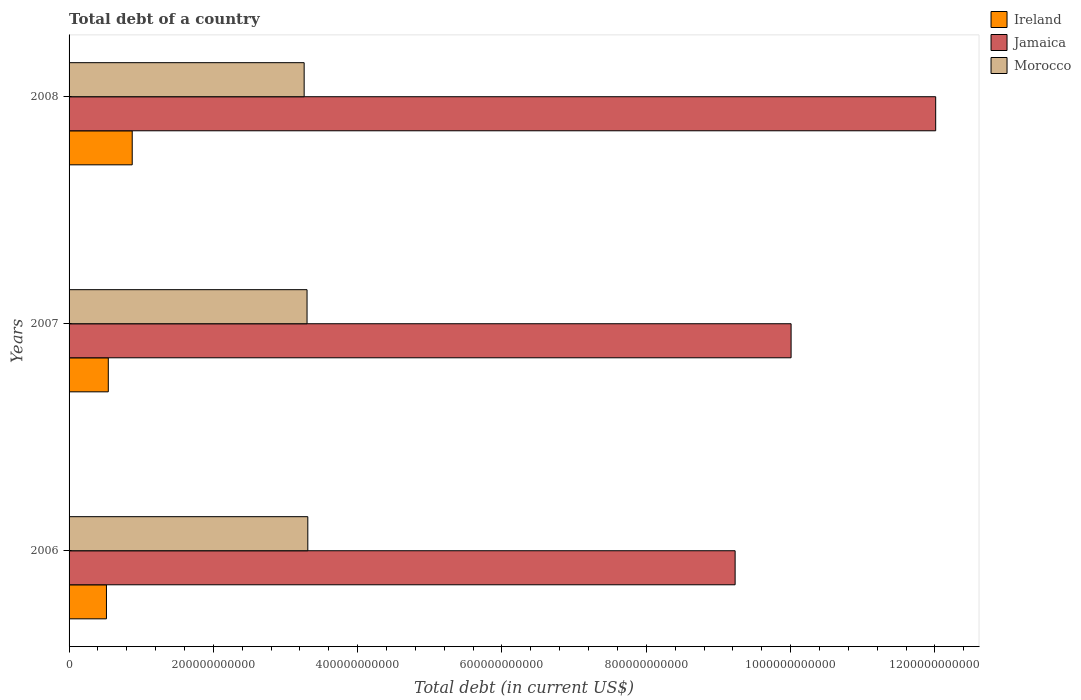Are the number of bars per tick equal to the number of legend labels?
Offer a very short reply. Yes. Are the number of bars on each tick of the Y-axis equal?
Your response must be concise. Yes. How many bars are there on the 3rd tick from the top?
Keep it short and to the point. 3. In how many cases, is the number of bars for a given year not equal to the number of legend labels?
Your answer should be very brief. 0. What is the debt in Ireland in 2008?
Make the answer very short. 8.75e+1. Across all years, what is the maximum debt in Morocco?
Offer a terse response. 3.31e+11. Across all years, what is the minimum debt in Jamaica?
Provide a succinct answer. 9.23e+11. What is the total debt in Morocco in the graph?
Your response must be concise. 9.87e+11. What is the difference between the debt in Jamaica in 2006 and that in 2007?
Make the answer very short. -7.76e+1. What is the difference between the debt in Ireland in 2006 and the debt in Jamaica in 2008?
Provide a succinct answer. -1.15e+12. What is the average debt in Ireland per year?
Your answer should be very brief. 6.46e+1. In the year 2008, what is the difference between the debt in Jamaica and debt in Ireland?
Ensure brevity in your answer.  1.11e+12. In how many years, is the debt in Ireland greater than 680000000000 US$?
Keep it short and to the point. 0. What is the ratio of the debt in Ireland in 2006 to that in 2007?
Provide a succinct answer. 0.95. What is the difference between the highest and the second highest debt in Ireland?
Ensure brevity in your answer.  3.32e+1. What is the difference between the highest and the lowest debt in Jamaica?
Keep it short and to the point. 2.78e+11. What does the 1st bar from the top in 2008 represents?
Offer a terse response. Morocco. What does the 2nd bar from the bottom in 2008 represents?
Your answer should be compact. Jamaica. Is it the case that in every year, the sum of the debt in Ireland and debt in Jamaica is greater than the debt in Morocco?
Your answer should be compact. Yes. How many bars are there?
Offer a very short reply. 9. Are all the bars in the graph horizontal?
Offer a terse response. Yes. How many years are there in the graph?
Your answer should be very brief. 3. What is the difference between two consecutive major ticks on the X-axis?
Your response must be concise. 2.00e+11. Are the values on the major ticks of X-axis written in scientific E-notation?
Offer a terse response. No. Does the graph contain any zero values?
Give a very brief answer. No. Where does the legend appear in the graph?
Make the answer very short. Top right. How are the legend labels stacked?
Your answer should be compact. Vertical. What is the title of the graph?
Your answer should be compact. Total debt of a country. What is the label or title of the X-axis?
Ensure brevity in your answer.  Total debt (in current US$). What is the Total debt (in current US$) in Ireland in 2006?
Offer a very short reply. 5.18e+1. What is the Total debt (in current US$) of Jamaica in 2006?
Your response must be concise. 9.23e+11. What is the Total debt (in current US$) in Morocco in 2006?
Make the answer very short. 3.31e+11. What is the Total debt (in current US$) in Ireland in 2007?
Keep it short and to the point. 5.44e+1. What is the Total debt (in current US$) in Jamaica in 2007?
Your answer should be compact. 1.00e+12. What is the Total debt (in current US$) in Morocco in 2007?
Your answer should be compact. 3.30e+11. What is the Total debt (in current US$) of Ireland in 2008?
Provide a short and direct response. 8.75e+1. What is the Total debt (in current US$) of Jamaica in 2008?
Offer a very short reply. 1.20e+12. What is the Total debt (in current US$) in Morocco in 2008?
Offer a very short reply. 3.26e+11. Across all years, what is the maximum Total debt (in current US$) of Ireland?
Give a very brief answer. 8.75e+1. Across all years, what is the maximum Total debt (in current US$) in Jamaica?
Your answer should be compact. 1.20e+12. Across all years, what is the maximum Total debt (in current US$) in Morocco?
Your answer should be very brief. 3.31e+11. Across all years, what is the minimum Total debt (in current US$) of Ireland?
Your answer should be very brief. 5.18e+1. Across all years, what is the minimum Total debt (in current US$) in Jamaica?
Make the answer very short. 9.23e+11. Across all years, what is the minimum Total debt (in current US$) of Morocco?
Give a very brief answer. 3.26e+11. What is the total Total debt (in current US$) in Ireland in the graph?
Your response must be concise. 1.94e+11. What is the total Total debt (in current US$) of Jamaica in the graph?
Give a very brief answer. 3.12e+12. What is the total Total debt (in current US$) in Morocco in the graph?
Give a very brief answer. 9.87e+11. What is the difference between the Total debt (in current US$) of Ireland in 2006 and that in 2007?
Provide a succinct answer. -2.56e+09. What is the difference between the Total debt (in current US$) of Jamaica in 2006 and that in 2007?
Give a very brief answer. -7.76e+1. What is the difference between the Total debt (in current US$) of Morocco in 2006 and that in 2007?
Offer a terse response. 1.06e+09. What is the difference between the Total debt (in current US$) in Ireland in 2006 and that in 2008?
Offer a terse response. -3.57e+1. What is the difference between the Total debt (in current US$) in Jamaica in 2006 and that in 2008?
Your answer should be compact. -2.78e+11. What is the difference between the Total debt (in current US$) of Morocco in 2006 and that in 2008?
Provide a succinct answer. 5.08e+09. What is the difference between the Total debt (in current US$) of Ireland in 2007 and that in 2008?
Give a very brief answer. -3.32e+1. What is the difference between the Total debt (in current US$) of Jamaica in 2007 and that in 2008?
Your answer should be compact. -2.00e+11. What is the difference between the Total debt (in current US$) in Morocco in 2007 and that in 2008?
Your response must be concise. 4.02e+09. What is the difference between the Total debt (in current US$) in Ireland in 2006 and the Total debt (in current US$) in Jamaica in 2007?
Offer a very short reply. -9.49e+11. What is the difference between the Total debt (in current US$) in Ireland in 2006 and the Total debt (in current US$) in Morocco in 2007?
Give a very brief answer. -2.78e+11. What is the difference between the Total debt (in current US$) of Jamaica in 2006 and the Total debt (in current US$) of Morocco in 2007?
Offer a very short reply. 5.93e+11. What is the difference between the Total debt (in current US$) in Ireland in 2006 and the Total debt (in current US$) in Jamaica in 2008?
Keep it short and to the point. -1.15e+12. What is the difference between the Total debt (in current US$) of Ireland in 2006 and the Total debt (in current US$) of Morocco in 2008?
Give a very brief answer. -2.74e+11. What is the difference between the Total debt (in current US$) in Jamaica in 2006 and the Total debt (in current US$) in Morocco in 2008?
Keep it short and to the point. 5.97e+11. What is the difference between the Total debt (in current US$) in Ireland in 2007 and the Total debt (in current US$) in Jamaica in 2008?
Provide a succinct answer. -1.15e+12. What is the difference between the Total debt (in current US$) in Ireland in 2007 and the Total debt (in current US$) in Morocco in 2008?
Your answer should be very brief. -2.71e+11. What is the difference between the Total debt (in current US$) of Jamaica in 2007 and the Total debt (in current US$) of Morocco in 2008?
Offer a terse response. 6.75e+11. What is the average Total debt (in current US$) in Ireland per year?
Ensure brevity in your answer.  6.46e+1. What is the average Total debt (in current US$) of Jamaica per year?
Keep it short and to the point. 1.04e+12. What is the average Total debt (in current US$) of Morocco per year?
Your answer should be compact. 3.29e+11. In the year 2006, what is the difference between the Total debt (in current US$) of Ireland and Total debt (in current US$) of Jamaica?
Make the answer very short. -8.71e+11. In the year 2006, what is the difference between the Total debt (in current US$) of Ireland and Total debt (in current US$) of Morocco?
Offer a very short reply. -2.79e+11. In the year 2006, what is the difference between the Total debt (in current US$) of Jamaica and Total debt (in current US$) of Morocco?
Your answer should be compact. 5.92e+11. In the year 2007, what is the difference between the Total debt (in current US$) in Ireland and Total debt (in current US$) in Jamaica?
Your answer should be very brief. -9.46e+11. In the year 2007, what is the difference between the Total debt (in current US$) of Ireland and Total debt (in current US$) of Morocco?
Provide a succinct answer. -2.75e+11. In the year 2007, what is the difference between the Total debt (in current US$) in Jamaica and Total debt (in current US$) in Morocco?
Offer a terse response. 6.71e+11. In the year 2008, what is the difference between the Total debt (in current US$) in Ireland and Total debt (in current US$) in Jamaica?
Offer a very short reply. -1.11e+12. In the year 2008, what is the difference between the Total debt (in current US$) of Ireland and Total debt (in current US$) of Morocco?
Keep it short and to the point. -2.38e+11. In the year 2008, what is the difference between the Total debt (in current US$) in Jamaica and Total debt (in current US$) in Morocco?
Keep it short and to the point. 8.75e+11. What is the ratio of the Total debt (in current US$) of Ireland in 2006 to that in 2007?
Make the answer very short. 0.95. What is the ratio of the Total debt (in current US$) in Jamaica in 2006 to that in 2007?
Make the answer very short. 0.92. What is the ratio of the Total debt (in current US$) in Ireland in 2006 to that in 2008?
Offer a terse response. 0.59. What is the ratio of the Total debt (in current US$) of Jamaica in 2006 to that in 2008?
Offer a very short reply. 0.77. What is the ratio of the Total debt (in current US$) of Morocco in 2006 to that in 2008?
Offer a very short reply. 1.02. What is the ratio of the Total debt (in current US$) of Ireland in 2007 to that in 2008?
Your answer should be very brief. 0.62. What is the ratio of the Total debt (in current US$) in Jamaica in 2007 to that in 2008?
Make the answer very short. 0.83. What is the ratio of the Total debt (in current US$) in Morocco in 2007 to that in 2008?
Offer a terse response. 1.01. What is the difference between the highest and the second highest Total debt (in current US$) of Ireland?
Ensure brevity in your answer.  3.32e+1. What is the difference between the highest and the second highest Total debt (in current US$) of Jamaica?
Provide a succinct answer. 2.00e+11. What is the difference between the highest and the second highest Total debt (in current US$) in Morocco?
Offer a very short reply. 1.06e+09. What is the difference between the highest and the lowest Total debt (in current US$) in Ireland?
Make the answer very short. 3.57e+1. What is the difference between the highest and the lowest Total debt (in current US$) in Jamaica?
Your response must be concise. 2.78e+11. What is the difference between the highest and the lowest Total debt (in current US$) in Morocco?
Offer a terse response. 5.08e+09. 